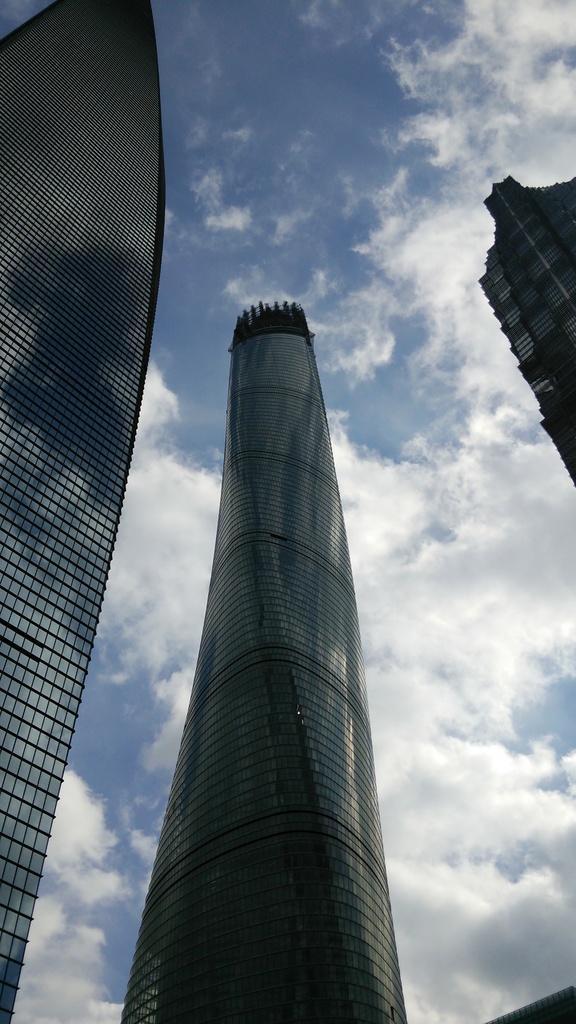In one or two sentences, can you explain what this image depicts? We can see buildings and sky with clouds. 